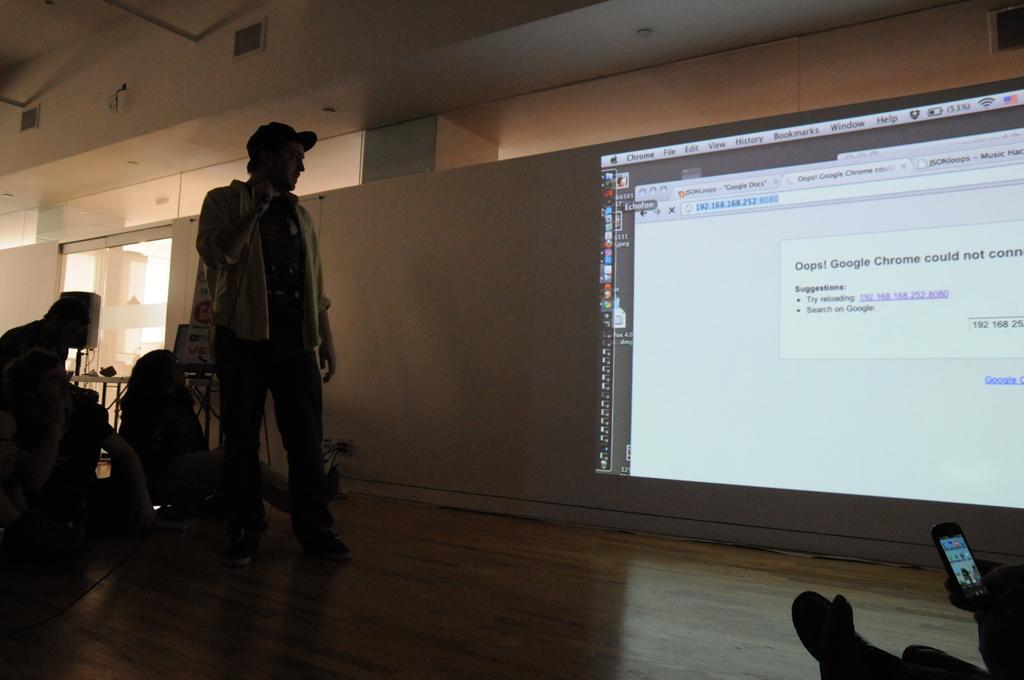Could you give a brief overview of what you see in this image? This image is clicked inside a room. There is a man standing on the floor. Behind him there is a wall. There is text displayed on the wall. There are a few people sitting on the floor. In the background there is a table. There are boards and speakers. There is a glass window to the wall. 